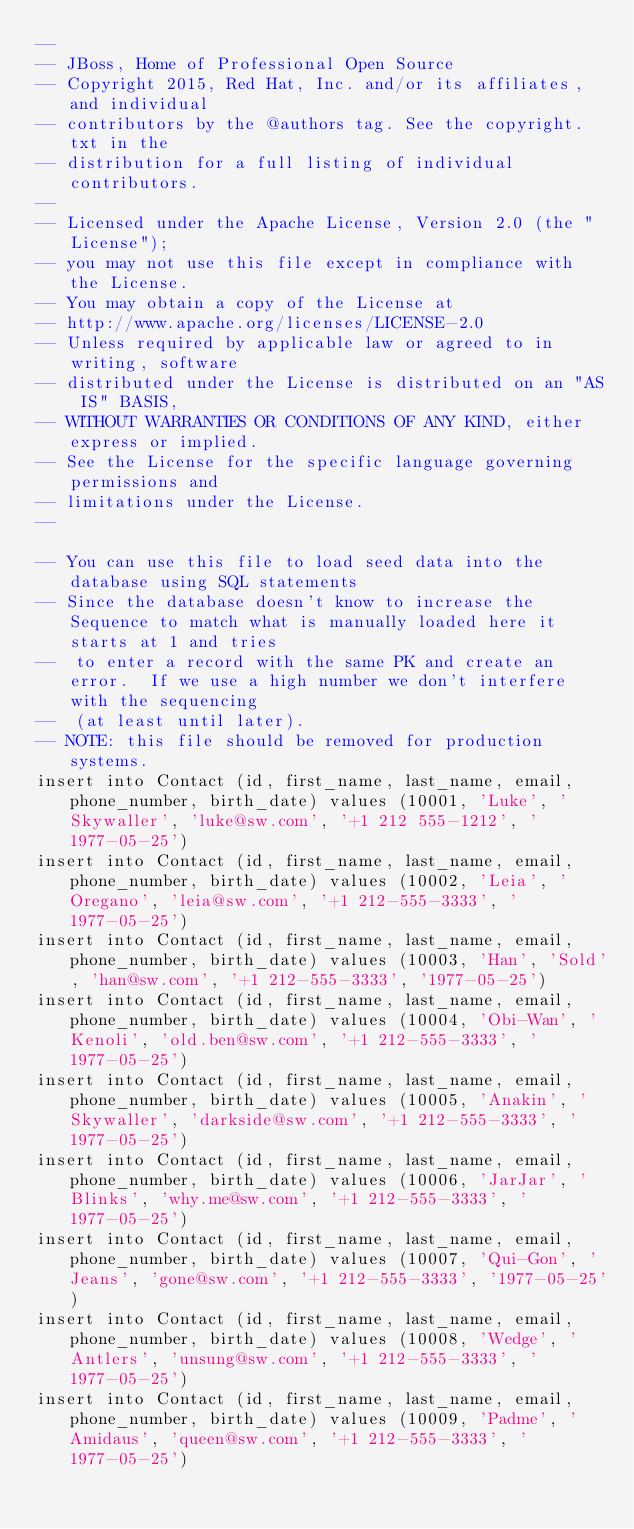<code> <loc_0><loc_0><loc_500><loc_500><_SQL_>--
-- JBoss, Home of Professional Open Source
-- Copyright 2015, Red Hat, Inc. and/or its affiliates, and individual
-- contributors by the @authors tag. See the copyright.txt in the
-- distribution for a full listing of individual contributors.
--
-- Licensed under the Apache License, Version 2.0 (the "License");
-- you may not use this file except in compliance with the License.
-- You may obtain a copy of the License at
-- http://www.apache.org/licenses/LICENSE-2.0
-- Unless required by applicable law or agreed to in writing, software
-- distributed under the License is distributed on an "AS IS" BASIS,
-- WITHOUT WARRANTIES OR CONDITIONS OF ANY KIND, either express or implied.
-- See the License for the specific language governing permissions and
-- limitations under the License.
--

-- You can use this file to load seed data into the database using SQL statements
-- Since the database doesn't know to increase the Sequence to match what is manually loaded here it starts at 1 and tries
--  to enter a record with the same PK and create an error.  If we use a high number we don't interfere with the sequencing 
--  (at least until later).
-- NOTE: this file should be removed for production systems. 
insert into Contact (id, first_name, last_name, email, phone_number, birth_date) values (10001, 'Luke', 'Skywaller', 'luke@sw.com', '+1 212 555-1212', '1977-05-25')
insert into Contact (id, first_name, last_name, email, phone_number, birth_date) values (10002, 'Leia', 'Oregano', 'leia@sw.com', '+1 212-555-3333', '1977-05-25')
insert into Contact (id, first_name, last_name, email, phone_number, birth_date) values (10003, 'Han', 'Sold', 'han@sw.com', '+1 212-555-3333', '1977-05-25')
insert into Contact (id, first_name, last_name, email, phone_number, birth_date) values (10004, 'Obi-Wan', 'Kenoli', 'old.ben@sw.com', '+1 212-555-3333', '1977-05-25')
insert into Contact (id, first_name, last_name, email, phone_number, birth_date) values (10005, 'Anakin', 'Skywaller', 'darkside@sw.com', '+1 212-555-3333', '1977-05-25')
insert into Contact (id, first_name, last_name, email, phone_number, birth_date) values (10006, 'JarJar', 'Blinks', 'why.me@sw.com', '+1 212-555-3333', '1977-05-25')
insert into Contact (id, first_name, last_name, email, phone_number, birth_date) values (10007, 'Qui-Gon', 'Jeans', 'gone@sw.com', '+1 212-555-3333', '1977-05-25')
insert into Contact (id, first_name, last_name, email, phone_number, birth_date) values (10008, 'Wedge', 'Antlers', 'unsung@sw.com', '+1 212-555-3333', '1977-05-25')
insert into Contact (id, first_name, last_name, email, phone_number, birth_date) values (10009, 'Padme', 'Amidaus', 'queen@sw.com', '+1 212-555-3333', '1977-05-25')
</code> 